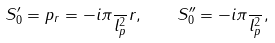<formula> <loc_0><loc_0><loc_500><loc_500>S ^ { \prime } _ { 0 } = p _ { r } = - i \pi \frac { } { l ^ { 2 } _ { p } } r , \quad S ^ { \prime \prime } _ { 0 } = - i \pi \frac { } { l ^ { 2 } _ { p } } ,</formula> 